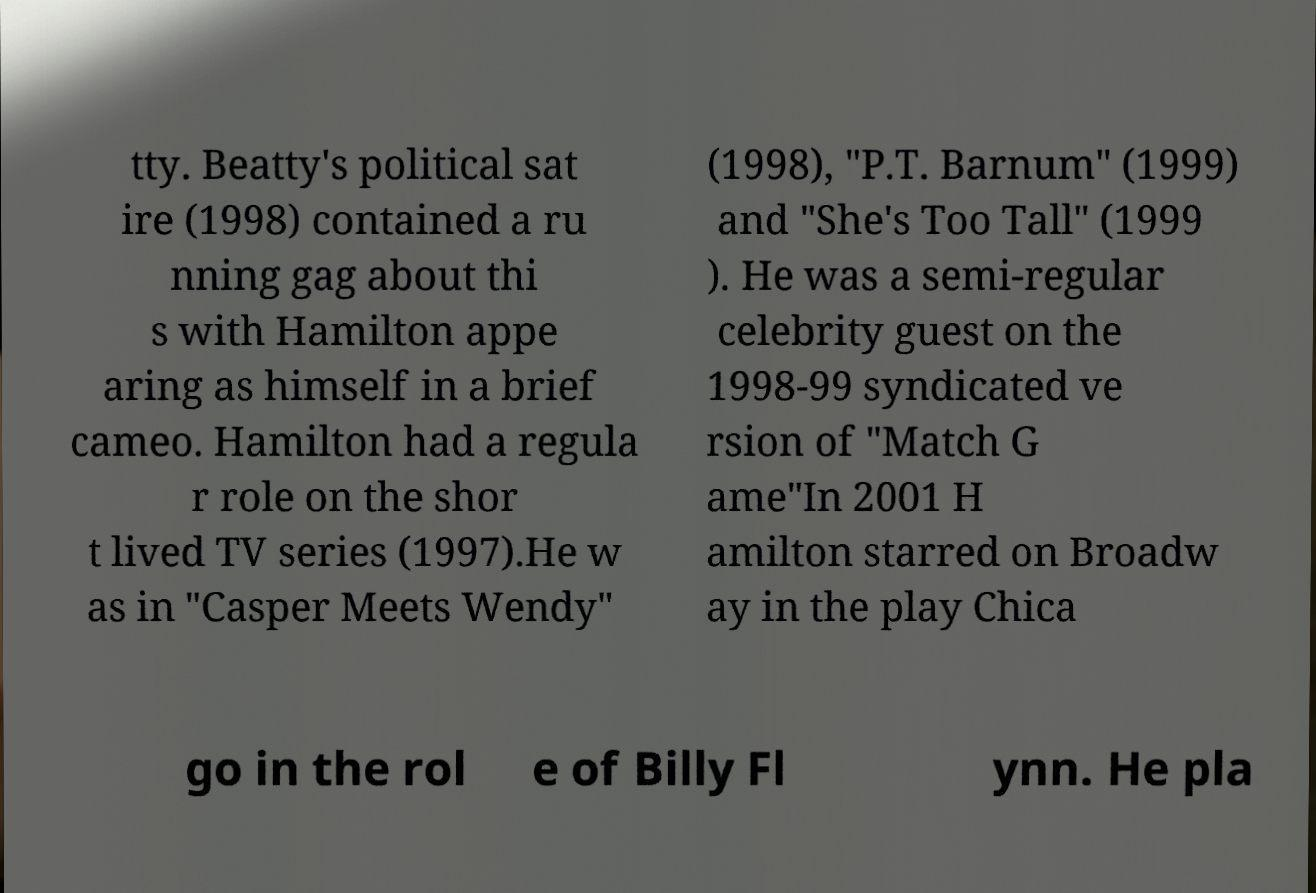Could you extract and type out the text from this image? tty. Beatty's political sat ire (1998) contained a ru nning gag about thi s with Hamilton appe aring as himself in a brief cameo. Hamilton had a regula r role on the shor t lived TV series (1997).He w as in "Casper Meets Wendy" (1998), "P.T. Barnum" (1999) and "She's Too Tall" (1999 ). He was a semi-regular celebrity guest on the 1998-99 syndicated ve rsion of "Match G ame"In 2001 H amilton starred on Broadw ay in the play Chica go in the rol e of Billy Fl ynn. He pla 